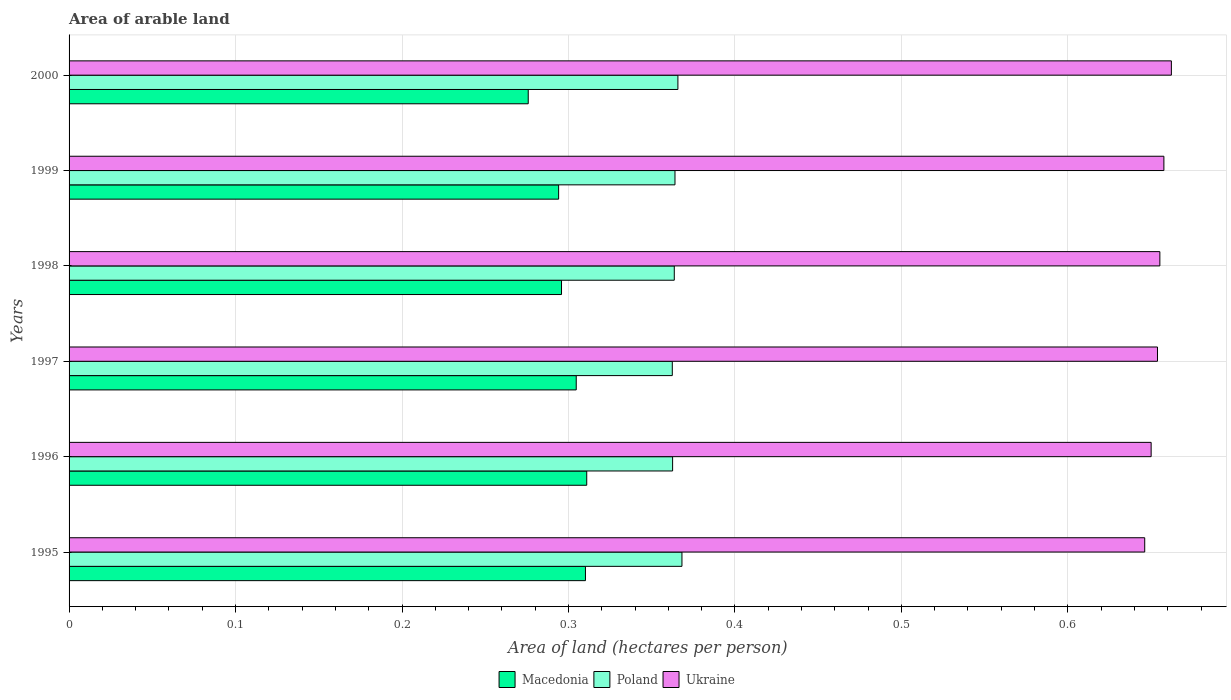How many different coloured bars are there?
Make the answer very short. 3. How many groups of bars are there?
Keep it short and to the point. 6. Are the number of bars per tick equal to the number of legend labels?
Provide a short and direct response. Yes. How many bars are there on the 3rd tick from the top?
Offer a very short reply. 3. What is the total arable land in Macedonia in 1997?
Make the answer very short. 0.3. Across all years, what is the maximum total arable land in Poland?
Your answer should be very brief. 0.37. Across all years, what is the minimum total arable land in Ukraine?
Your answer should be compact. 0.65. What is the total total arable land in Macedonia in the graph?
Provide a succinct answer. 1.79. What is the difference between the total arable land in Macedonia in 1996 and that in 1998?
Your response must be concise. 0.02. What is the difference between the total arable land in Macedonia in 2000 and the total arable land in Poland in 1995?
Your response must be concise. -0.09. What is the average total arable land in Macedonia per year?
Make the answer very short. 0.3. In the year 1996, what is the difference between the total arable land in Ukraine and total arable land in Macedonia?
Provide a short and direct response. 0.34. What is the ratio of the total arable land in Macedonia in 1995 to that in 1998?
Give a very brief answer. 1.05. Is the difference between the total arable land in Ukraine in 1997 and 1998 greater than the difference between the total arable land in Macedonia in 1997 and 1998?
Provide a succinct answer. No. What is the difference between the highest and the second highest total arable land in Poland?
Your response must be concise. 0. What is the difference between the highest and the lowest total arable land in Poland?
Provide a succinct answer. 0.01. In how many years, is the total arable land in Poland greater than the average total arable land in Poland taken over all years?
Ensure brevity in your answer.  2. What does the 2nd bar from the top in 1995 represents?
Your response must be concise. Poland. How many years are there in the graph?
Your answer should be very brief. 6. What is the difference between two consecutive major ticks on the X-axis?
Keep it short and to the point. 0.1. Are the values on the major ticks of X-axis written in scientific E-notation?
Keep it short and to the point. No. Does the graph contain any zero values?
Your response must be concise. No. Does the graph contain grids?
Your answer should be compact. Yes. How many legend labels are there?
Your answer should be very brief. 3. How are the legend labels stacked?
Give a very brief answer. Horizontal. What is the title of the graph?
Keep it short and to the point. Area of arable land. What is the label or title of the X-axis?
Provide a short and direct response. Area of land (hectares per person). What is the label or title of the Y-axis?
Offer a very short reply. Years. What is the Area of land (hectares per person) in Macedonia in 1995?
Give a very brief answer. 0.31. What is the Area of land (hectares per person) of Poland in 1995?
Give a very brief answer. 0.37. What is the Area of land (hectares per person) in Ukraine in 1995?
Keep it short and to the point. 0.65. What is the Area of land (hectares per person) of Macedonia in 1996?
Your answer should be very brief. 0.31. What is the Area of land (hectares per person) of Poland in 1996?
Your answer should be compact. 0.36. What is the Area of land (hectares per person) in Ukraine in 1996?
Offer a terse response. 0.65. What is the Area of land (hectares per person) in Macedonia in 1997?
Provide a succinct answer. 0.3. What is the Area of land (hectares per person) of Poland in 1997?
Offer a very short reply. 0.36. What is the Area of land (hectares per person) in Ukraine in 1997?
Make the answer very short. 0.65. What is the Area of land (hectares per person) of Macedonia in 1998?
Your response must be concise. 0.3. What is the Area of land (hectares per person) of Poland in 1998?
Provide a succinct answer. 0.36. What is the Area of land (hectares per person) of Ukraine in 1998?
Provide a succinct answer. 0.66. What is the Area of land (hectares per person) of Macedonia in 1999?
Make the answer very short. 0.29. What is the Area of land (hectares per person) of Poland in 1999?
Make the answer very short. 0.36. What is the Area of land (hectares per person) in Ukraine in 1999?
Offer a terse response. 0.66. What is the Area of land (hectares per person) in Macedonia in 2000?
Ensure brevity in your answer.  0.28. What is the Area of land (hectares per person) in Poland in 2000?
Give a very brief answer. 0.37. What is the Area of land (hectares per person) in Ukraine in 2000?
Offer a terse response. 0.66. Across all years, what is the maximum Area of land (hectares per person) in Macedonia?
Your response must be concise. 0.31. Across all years, what is the maximum Area of land (hectares per person) in Poland?
Provide a succinct answer. 0.37. Across all years, what is the maximum Area of land (hectares per person) of Ukraine?
Ensure brevity in your answer.  0.66. Across all years, what is the minimum Area of land (hectares per person) in Macedonia?
Provide a short and direct response. 0.28. Across all years, what is the minimum Area of land (hectares per person) of Poland?
Offer a very short reply. 0.36. Across all years, what is the minimum Area of land (hectares per person) in Ukraine?
Offer a terse response. 0.65. What is the total Area of land (hectares per person) of Macedonia in the graph?
Provide a succinct answer. 1.79. What is the total Area of land (hectares per person) in Poland in the graph?
Provide a short and direct response. 2.19. What is the total Area of land (hectares per person) of Ukraine in the graph?
Your answer should be compact. 3.93. What is the difference between the Area of land (hectares per person) in Macedonia in 1995 and that in 1996?
Your response must be concise. -0. What is the difference between the Area of land (hectares per person) in Poland in 1995 and that in 1996?
Provide a succinct answer. 0.01. What is the difference between the Area of land (hectares per person) of Ukraine in 1995 and that in 1996?
Offer a terse response. -0. What is the difference between the Area of land (hectares per person) in Macedonia in 1995 and that in 1997?
Provide a succinct answer. 0.01. What is the difference between the Area of land (hectares per person) in Poland in 1995 and that in 1997?
Ensure brevity in your answer.  0.01. What is the difference between the Area of land (hectares per person) of Ukraine in 1995 and that in 1997?
Offer a very short reply. -0.01. What is the difference between the Area of land (hectares per person) in Macedonia in 1995 and that in 1998?
Your response must be concise. 0.01. What is the difference between the Area of land (hectares per person) of Poland in 1995 and that in 1998?
Your answer should be compact. 0. What is the difference between the Area of land (hectares per person) in Ukraine in 1995 and that in 1998?
Offer a terse response. -0.01. What is the difference between the Area of land (hectares per person) of Macedonia in 1995 and that in 1999?
Keep it short and to the point. 0.02. What is the difference between the Area of land (hectares per person) in Poland in 1995 and that in 1999?
Keep it short and to the point. 0. What is the difference between the Area of land (hectares per person) in Ukraine in 1995 and that in 1999?
Offer a very short reply. -0.01. What is the difference between the Area of land (hectares per person) of Macedonia in 1995 and that in 2000?
Offer a terse response. 0.03. What is the difference between the Area of land (hectares per person) in Poland in 1995 and that in 2000?
Your answer should be compact. 0. What is the difference between the Area of land (hectares per person) of Ukraine in 1995 and that in 2000?
Make the answer very short. -0.02. What is the difference between the Area of land (hectares per person) in Macedonia in 1996 and that in 1997?
Your answer should be compact. 0.01. What is the difference between the Area of land (hectares per person) of Ukraine in 1996 and that in 1997?
Provide a succinct answer. -0. What is the difference between the Area of land (hectares per person) of Macedonia in 1996 and that in 1998?
Ensure brevity in your answer.  0.02. What is the difference between the Area of land (hectares per person) in Poland in 1996 and that in 1998?
Give a very brief answer. -0. What is the difference between the Area of land (hectares per person) in Ukraine in 1996 and that in 1998?
Offer a very short reply. -0.01. What is the difference between the Area of land (hectares per person) of Macedonia in 1996 and that in 1999?
Your answer should be very brief. 0.02. What is the difference between the Area of land (hectares per person) in Poland in 1996 and that in 1999?
Keep it short and to the point. -0. What is the difference between the Area of land (hectares per person) of Ukraine in 1996 and that in 1999?
Make the answer very short. -0.01. What is the difference between the Area of land (hectares per person) in Macedonia in 1996 and that in 2000?
Make the answer very short. 0.04. What is the difference between the Area of land (hectares per person) in Poland in 1996 and that in 2000?
Offer a terse response. -0. What is the difference between the Area of land (hectares per person) in Ukraine in 1996 and that in 2000?
Keep it short and to the point. -0.01. What is the difference between the Area of land (hectares per person) of Macedonia in 1997 and that in 1998?
Your response must be concise. 0.01. What is the difference between the Area of land (hectares per person) in Poland in 1997 and that in 1998?
Keep it short and to the point. -0. What is the difference between the Area of land (hectares per person) in Ukraine in 1997 and that in 1998?
Keep it short and to the point. -0. What is the difference between the Area of land (hectares per person) in Macedonia in 1997 and that in 1999?
Provide a short and direct response. 0.01. What is the difference between the Area of land (hectares per person) in Poland in 1997 and that in 1999?
Your answer should be very brief. -0. What is the difference between the Area of land (hectares per person) of Ukraine in 1997 and that in 1999?
Make the answer very short. -0. What is the difference between the Area of land (hectares per person) of Macedonia in 1997 and that in 2000?
Your response must be concise. 0.03. What is the difference between the Area of land (hectares per person) of Poland in 1997 and that in 2000?
Offer a terse response. -0. What is the difference between the Area of land (hectares per person) of Ukraine in 1997 and that in 2000?
Provide a short and direct response. -0.01. What is the difference between the Area of land (hectares per person) in Macedonia in 1998 and that in 1999?
Keep it short and to the point. 0. What is the difference between the Area of land (hectares per person) of Poland in 1998 and that in 1999?
Offer a very short reply. -0. What is the difference between the Area of land (hectares per person) in Ukraine in 1998 and that in 1999?
Offer a terse response. -0. What is the difference between the Area of land (hectares per person) of Poland in 1998 and that in 2000?
Offer a very short reply. -0. What is the difference between the Area of land (hectares per person) in Ukraine in 1998 and that in 2000?
Provide a short and direct response. -0.01. What is the difference between the Area of land (hectares per person) in Macedonia in 1999 and that in 2000?
Keep it short and to the point. 0.02. What is the difference between the Area of land (hectares per person) in Poland in 1999 and that in 2000?
Offer a terse response. -0. What is the difference between the Area of land (hectares per person) in Ukraine in 1999 and that in 2000?
Give a very brief answer. -0. What is the difference between the Area of land (hectares per person) in Macedonia in 1995 and the Area of land (hectares per person) in Poland in 1996?
Provide a short and direct response. -0.05. What is the difference between the Area of land (hectares per person) of Macedonia in 1995 and the Area of land (hectares per person) of Ukraine in 1996?
Give a very brief answer. -0.34. What is the difference between the Area of land (hectares per person) in Poland in 1995 and the Area of land (hectares per person) in Ukraine in 1996?
Make the answer very short. -0.28. What is the difference between the Area of land (hectares per person) in Macedonia in 1995 and the Area of land (hectares per person) in Poland in 1997?
Provide a succinct answer. -0.05. What is the difference between the Area of land (hectares per person) of Macedonia in 1995 and the Area of land (hectares per person) of Ukraine in 1997?
Make the answer very short. -0.34. What is the difference between the Area of land (hectares per person) of Poland in 1995 and the Area of land (hectares per person) of Ukraine in 1997?
Offer a terse response. -0.29. What is the difference between the Area of land (hectares per person) in Macedonia in 1995 and the Area of land (hectares per person) in Poland in 1998?
Keep it short and to the point. -0.05. What is the difference between the Area of land (hectares per person) of Macedonia in 1995 and the Area of land (hectares per person) of Ukraine in 1998?
Provide a succinct answer. -0.35. What is the difference between the Area of land (hectares per person) in Poland in 1995 and the Area of land (hectares per person) in Ukraine in 1998?
Offer a terse response. -0.29. What is the difference between the Area of land (hectares per person) in Macedonia in 1995 and the Area of land (hectares per person) in Poland in 1999?
Provide a succinct answer. -0.05. What is the difference between the Area of land (hectares per person) in Macedonia in 1995 and the Area of land (hectares per person) in Ukraine in 1999?
Your answer should be compact. -0.35. What is the difference between the Area of land (hectares per person) of Poland in 1995 and the Area of land (hectares per person) of Ukraine in 1999?
Your response must be concise. -0.29. What is the difference between the Area of land (hectares per person) of Macedonia in 1995 and the Area of land (hectares per person) of Poland in 2000?
Make the answer very short. -0.06. What is the difference between the Area of land (hectares per person) in Macedonia in 1995 and the Area of land (hectares per person) in Ukraine in 2000?
Give a very brief answer. -0.35. What is the difference between the Area of land (hectares per person) of Poland in 1995 and the Area of land (hectares per person) of Ukraine in 2000?
Keep it short and to the point. -0.29. What is the difference between the Area of land (hectares per person) in Macedonia in 1996 and the Area of land (hectares per person) in Poland in 1997?
Your answer should be compact. -0.05. What is the difference between the Area of land (hectares per person) of Macedonia in 1996 and the Area of land (hectares per person) of Ukraine in 1997?
Provide a succinct answer. -0.34. What is the difference between the Area of land (hectares per person) in Poland in 1996 and the Area of land (hectares per person) in Ukraine in 1997?
Your answer should be compact. -0.29. What is the difference between the Area of land (hectares per person) of Macedonia in 1996 and the Area of land (hectares per person) of Poland in 1998?
Offer a very short reply. -0.05. What is the difference between the Area of land (hectares per person) in Macedonia in 1996 and the Area of land (hectares per person) in Ukraine in 1998?
Provide a short and direct response. -0.34. What is the difference between the Area of land (hectares per person) in Poland in 1996 and the Area of land (hectares per person) in Ukraine in 1998?
Offer a terse response. -0.29. What is the difference between the Area of land (hectares per person) in Macedonia in 1996 and the Area of land (hectares per person) in Poland in 1999?
Your answer should be compact. -0.05. What is the difference between the Area of land (hectares per person) in Macedonia in 1996 and the Area of land (hectares per person) in Ukraine in 1999?
Keep it short and to the point. -0.35. What is the difference between the Area of land (hectares per person) of Poland in 1996 and the Area of land (hectares per person) of Ukraine in 1999?
Keep it short and to the point. -0.3. What is the difference between the Area of land (hectares per person) of Macedonia in 1996 and the Area of land (hectares per person) of Poland in 2000?
Your response must be concise. -0.05. What is the difference between the Area of land (hectares per person) in Macedonia in 1996 and the Area of land (hectares per person) in Ukraine in 2000?
Your answer should be very brief. -0.35. What is the difference between the Area of land (hectares per person) of Poland in 1996 and the Area of land (hectares per person) of Ukraine in 2000?
Offer a terse response. -0.3. What is the difference between the Area of land (hectares per person) in Macedonia in 1997 and the Area of land (hectares per person) in Poland in 1998?
Your response must be concise. -0.06. What is the difference between the Area of land (hectares per person) in Macedonia in 1997 and the Area of land (hectares per person) in Ukraine in 1998?
Offer a very short reply. -0.35. What is the difference between the Area of land (hectares per person) of Poland in 1997 and the Area of land (hectares per person) of Ukraine in 1998?
Provide a short and direct response. -0.29. What is the difference between the Area of land (hectares per person) in Macedonia in 1997 and the Area of land (hectares per person) in Poland in 1999?
Make the answer very short. -0.06. What is the difference between the Area of land (hectares per person) of Macedonia in 1997 and the Area of land (hectares per person) of Ukraine in 1999?
Offer a very short reply. -0.35. What is the difference between the Area of land (hectares per person) of Poland in 1997 and the Area of land (hectares per person) of Ukraine in 1999?
Keep it short and to the point. -0.3. What is the difference between the Area of land (hectares per person) in Macedonia in 1997 and the Area of land (hectares per person) in Poland in 2000?
Keep it short and to the point. -0.06. What is the difference between the Area of land (hectares per person) in Macedonia in 1997 and the Area of land (hectares per person) in Ukraine in 2000?
Offer a terse response. -0.36. What is the difference between the Area of land (hectares per person) of Poland in 1997 and the Area of land (hectares per person) of Ukraine in 2000?
Offer a terse response. -0.3. What is the difference between the Area of land (hectares per person) in Macedonia in 1998 and the Area of land (hectares per person) in Poland in 1999?
Ensure brevity in your answer.  -0.07. What is the difference between the Area of land (hectares per person) in Macedonia in 1998 and the Area of land (hectares per person) in Ukraine in 1999?
Offer a terse response. -0.36. What is the difference between the Area of land (hectares per person) in Poland in 1998 and the Area of land (hectares per person) in Ukraine in 1999?
Offer a terse response. -0.29. What is the difference between the Area of land (hectares per person) of Macedonia in 1998 and the Area of land (hectares per person) of Poland in 2000?
Your response must be concise. -0.07. What is the difference between the Area of land (hectares per person) of Macedonia in 1998 and the Area of land (hectares per person) of Ukraine in 2000?
Your answer should be very brief. -0.37. What is the difference between the Area of land (hectares per person) in Poland in 1998 and the Area of land (hectares per person) in Ukraine in 2000?
Your answer should be very brief. -0.3. What is the difference between the Area of land (hectares per person) in Macedonia in 1999 and the Area of land (hectares per person) in Poland in 2000?
Offer a terse response. -0.07. What is the difference between the Area of land (hectares per person) of Macedonia in 1999 and the Area of land (hectares per person) of Ukraine in 2000?
Keep it short and to the point. -0.37. What is the difference between the Area of land (hectares per person) of Poland in 1999 and the Area of land (hectares per person) of Ukraine in 2000?
Offer a very short reply. -0.3. What is the average Area of land (hectares per person) in Macedonia per year?
Your answer should be very brief. 0.3. What is the average Area of land (hectares per person) of Poland per year?
Offer a terse response. 0.36. What is the average Area of land (hectares per person) in Ukraine per year?
Offer a very short reply. 0.65. In the year 1995, what is the difference between the Area of land (hectares per person) in Macedonia and Area of land (hectares per person) in Poland?
Provide a succinct answer. -0.06. In the year 1995, what is the difference between the Area of land (hectares per person) in Macedonia and Area of land (hectares per person) in Ukraine?
Give a very brief answer. -0.34. In the year 1995, what is the difference between the Area of land (hectares per person) in Poland and Area of land (hectares per person) in Ukraine?
Offer a terse response. -0.28. In the year 1996, what is the difference between the Area of land (hectares per person) in Macedonia and Area of land (hectares per person) in Poland?
Provide a short and direct response. -0.05. In the year 1996, what is the difference between the Area of land (hectares per person) of Macedonia and Area of land (hectares per person) of Ukraine?
Your response must be concise. -0.34. In the year 1996, what is the difference between the Area of land (hectares per person) in Poland and Area of land (hectares per person) in Ukraine?
Your response must be concise. -0.29. In the year 1997, what is the difference between the Area of land (hectares per person) of Macedonia and Area of land (hectares per person) of Poland?
Provide a short and direct response. -0.06. In the year 1997, what is the difference between the Area of land (hectares per person) of Macedonia and Area of land (hectares per person) of Ukraine?
Ensure brevity in your answer.  -0.35. In the year 1997, what is the difference between the Area of land (hectares per person) in Poland and Area of land (hectares per person) in Ukraine?
Keep it short and to the point. -0.29. In the year 1998, what is the difference between the Area of land (hectares per person) of Macedonia and Area of land (hectares per person) of Poland?
Your response must be concise. -0.07. In the year 1998, what is the difference between the Area of land (hectares per person) in Macedonia and Area of land (hectares per person) in Ukraine?
Offer a terse response. -0.36. In the year 1998, what is the difference between the Area of land (hectares per person) in Poland and Area of land (hectares per person) in Ukraine?
Your answer should be very brief. -0.29. In the year 1999, what is the difference between the Area of land (hectares per person) in Macedonia and Area of land (hectares per person) in Poland?
Your answer should be very brief. -0.07. In the year 1999, what is the difference between the Area of land (hectares per person) in Macedonia and Area of land (hectares per person) in Ukraine?
Your answer should be very brief. -0.36. In the year 1999, what is the difference between the Area of land (hectares per person) of Poland and Area of land (hectares per person) of Ukraine?
Provide a short and direct response. -0.29. In the year 2000, what is the difference between the Area of land (hectares per person) of Macedonia and Area of land (hectares per person) of Poland?
Make the answer very short. -0.09. In the year 2000, what is the difference between the Area of land (hectares per person) of Macedonia and Area of land (hectares per person) of Ukraine?
Offer a terse response. -0.39. In the year 2000, what is the difference between the Area of land (hectares per person) in Poland and Area of land (hectares per person) in Ukraine?
Give a very brief answer. -0.3. What is the ratio of the Area of land (hectares per person) in Poland in 1995 to that in 1996?
Your answer should be very brief. 1.02. What is the ratio of the Area of land (hectares per person) in Macedonia in 1995 to that in 1997?
Offer a very short reply. 1.02. What is the ratio of the Area of land (hectares per person) in Poland in 1995 to that in 1997?
Provide a short and direct response. 1.02. What is the ratio of the Area of land (hectares per person) of Ukraine in 1995 to that in 1997?
Offer a terse response. 0.99. What is the ratio of the Area of land (hectares per person) of Macedonia in 1995 to that in 1998?
Provide a short and direct response. 1.05. What is the ratio of the Area of land (hectares per person) in Poland in 1995 to that in 1998?
Ensure brevity in your answer.  1.01. What is the ratio of the Area of land (hectares per person) in Ukraine in 1995 to that in 1998?
Your answer should be compact. 0.99. What is the ratio of the Area of land (hectares per person) in Macedonia in 1995 to that in 1999?
Ensure brevity in your answer.  1.05. What is the ratio of the Area of land (hectares per person) in Poland in 1995 to that in 1999?
Offer a very short reply. 1.01. What is the ratio of the Area of land (hectares per person) of Ukraine in 1995 to that in 1999?
Give a very brief answer. 0.98. What is the ratio of the Area of land (hectares per person) of Macedonia in 1995 to that in 2000?
Provide a succinct answer. 1.12. What is the ratio of the Area of land (hectares per person) in Poland in 1995 to that in 2000?
Your answer should be compact. 1.01. What is the ratio of the Area of land (hectares per person) in Ukraine in 1995 to that in 2000?
Your response must be concise. 0.98. What is the ratio of the Area of land (hectares per person) of Macedonia in 1996 to that in 1997?
Keep it short and to the point. 1.02. What is the ratio of the Area of land (hectares per person) in Poland in 1996 to that in 1997?
Your answer should be compact. 1. What is the ratio of the Area of land (hectares per person) in Macedonia in 1996 to that in 1998?
Your answer should be compact. 1.05. What is the ratio of the Area of land (hectares per person) in Poland in 1996 to that in 1998?
Offer a very short reply. 1. What is the ratio of the Area of land (hectares per person) in Ukraine in 1996 to that in 1998?
Make the answer very short. 0.99. What is the ratio of the Area of land (hectares per person) of Macedonia in 1996 to that in 1999?
Your response must be concise. 1.06. What is the ratio of the Area of land (hectares per person) in Ukraine in 1996 to that in 1999?
Provide a succinct answer. 0.99. What is the ratio of the Area of land (hectares per person) in Macedonia in 1996 to that in 2000?
Make the answer very short. 1.13. What is the ratio of the Area of land (hectares per person) of Ukraine in 1996 to that in 2000?
Ensure brevity in your answer.  0.98. What is the ratio of the Area of land (hectares per person) in Macedonia in 1997 to that in 1998?
Offer a terse response. 1.03. What is the ratio of the Area of land (hectares per person) in Poland in 1997 to that in 1998?
Your answer should be compact. 1. What is the ratio of the Area of land (hectares per person) in Ukraine in 1997 to that in 1998?
Make the answer very short. 1. What is the ratio of the Area of land (hectares per person) in Macedonia in 1997 to that in 1999?
Your response must be concise. 1.04. What is the ratio of the Area of land (hectares per person) in Poland in 1997 to that in 1999?
Provide a succinct answer. 1. What is the ratio of the Area of land (hectares per person) of Ukraine in 1997 to that in 1999?
Provide a short and direct response. 0.99. What is the ratio of the Area of land (hectares per person) of Macedonia in 1997 to that in 2000?
Your answer should be compact. 1.1. What is the ratio of the Area of land (hectares per person) of Poland in 1997 to that in 2000?
Keep it short and to the point. 0.99. What is the ratio of the Area of land (hectares per person) of Ukraine in 1997 to that in 2000?
Your response must be concise. 0.99. What is the ratio of the Area of land (hectares per person) in Macedonia in 1998 to that in 1999?
Make the answer very short. 1.01. What is the ratio of the Area of land (hectares per person) in Ukraine in 1998 to that in 1999?
Keep it short and to the point. 1. What is the ratio of the Area of land (hectares per person) of Macedonia in 1998 to that in 2000?
Make the answer very short. 1.07. What is the ratio of the Area of land (hectares per person) in Poland in 1998 to that in 2000?
Make the answer very short. 0.99. What is the ratio of the Area of land (hectares per person) of Ukraine in 1998 to that in 2000?
Your answer should be very brief. 0.99. What is the ratio of the Area of land (hectares per person) of Macedonia in 1999 to that in 2000?
Provide a succinct answer. 1.07. What is the ratio of the Area of land (hectares per person) in Poland in 1999 to that in 2000?
Your answer should be very brief. 1. What is the ratio of the Area of land (hectares per person) of Ukraine in 1999 to that in 2000?
Provide a short and direct response. 0.99. What is the difference between the highest and the second highest Area of land (hectares per person) of Macedonia?
Offer a very short reply. 0. What is the difference between the highest and the second highest Area of land (hectares per person) in Poland?
Your answer should be compact. 0. What is the difference between the highest and the second highest Area of land (hectares per person) in Ukraine?
Give a very brief answer. 0. What is the difference between the highest and the lowest Area of land (hectares per person) of Macedonia?
Your answer should be compact. 0.04. What is the difference between the highest and the lowest Area of land (hectares per person) of Poland?
Offer a terse response. 0.01. What is the difference between the highest and the lowest Area of land (hectares per person) of Ukraine?
Give a very brief answer. 0.02. 